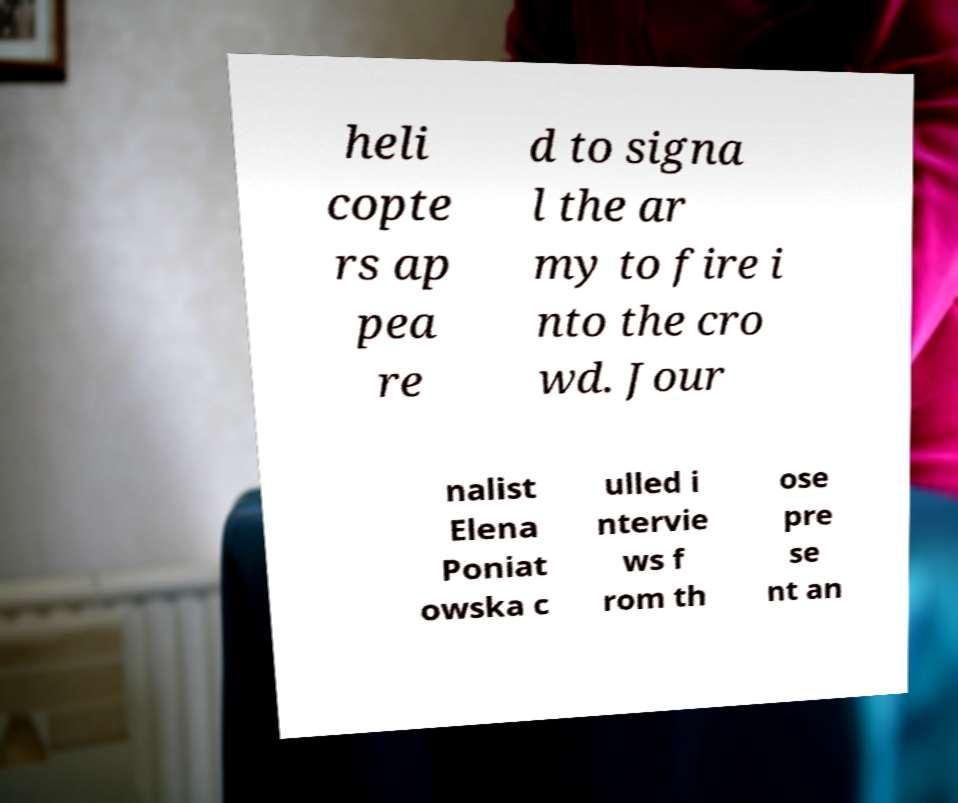For documentation purposes, I need the text within this image transcribed. Could you provide that? heli copte rs ap pea re d to signa l the ar my to fire i nto the cro wd. Jour nalist Elena Poniat owska c ulled i ntervie ws f rom th ose pre se nt an 